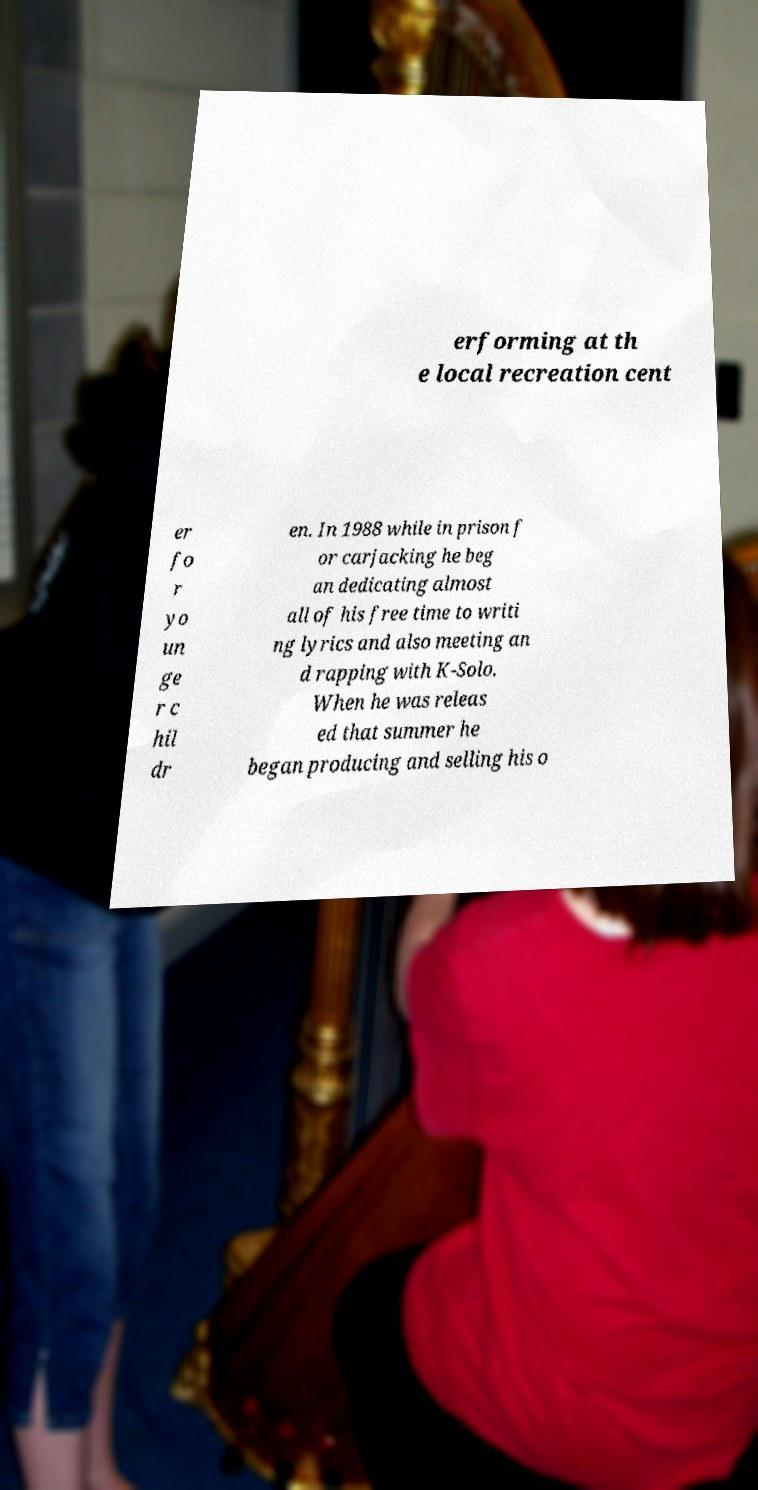For documentation purposes, I need the text within this image transcribed. Could you provide that? erforming at th e local recreation cent er fo r yo un ge r c hil dr en. In 1988 while in prison f or carjacking he beg an dedicating almost all of his free time to writi ng lyrics and also meeting an d rapping with K-Solo. When he was releas ed that summer he began producing and selling his o 